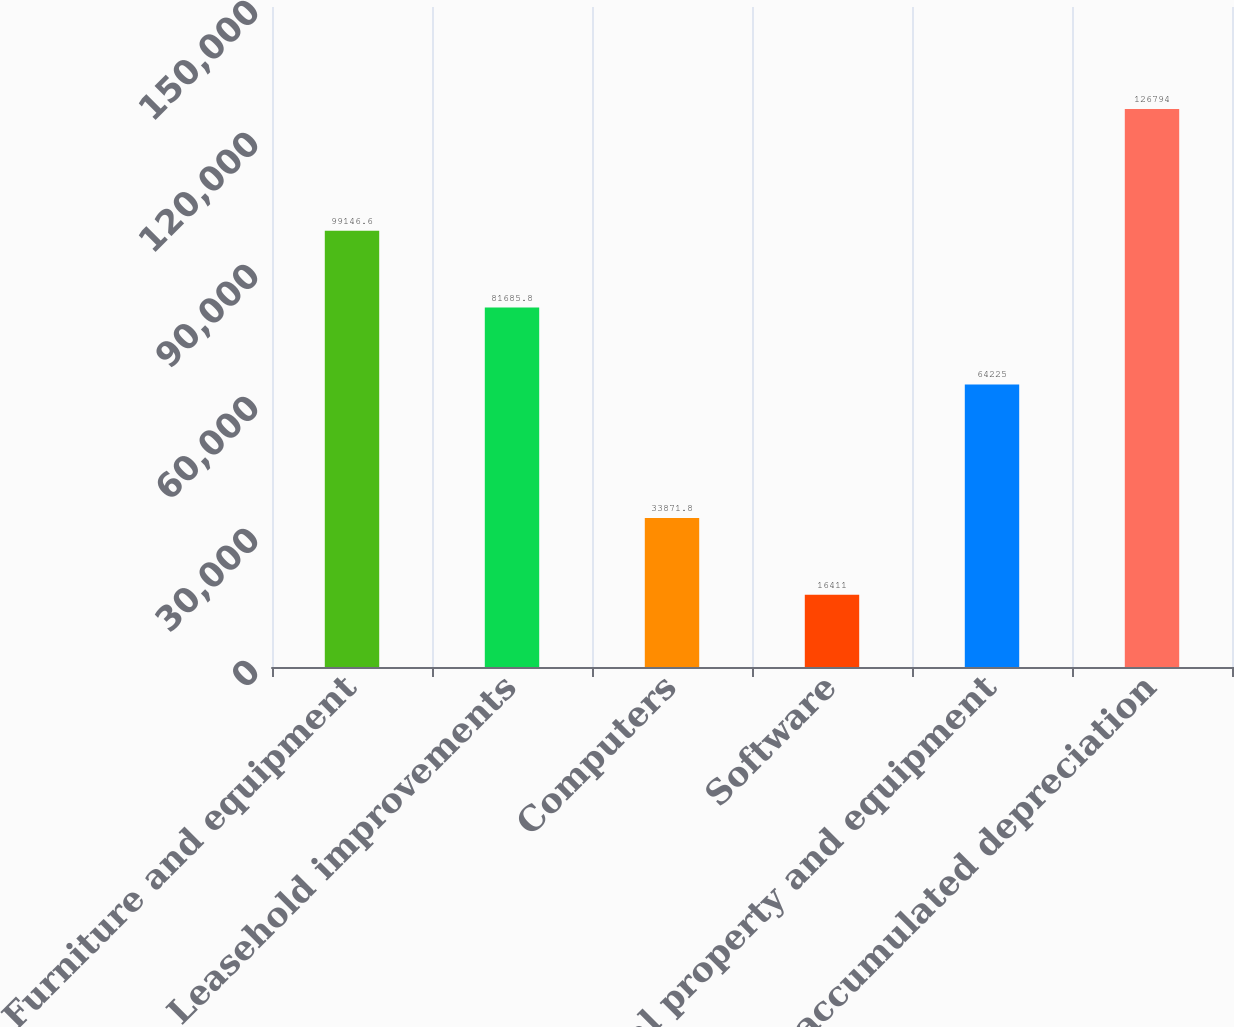Convert chart to OTSL. <chart><loc_0><loc_0><loc_500><loc_500><bar_chart><fcel>Furniture and equipment<fcel>Leasehold improvements<fcel>Computers<fcel>Software<fcel>Total property and equipment<fcel>Less accumulated depreciation<nl><fcel>99146.6<fcel>81685.8<fcel>33871.8<fcel>16411<fcel>64225<fcel>126794<nl></chart> 